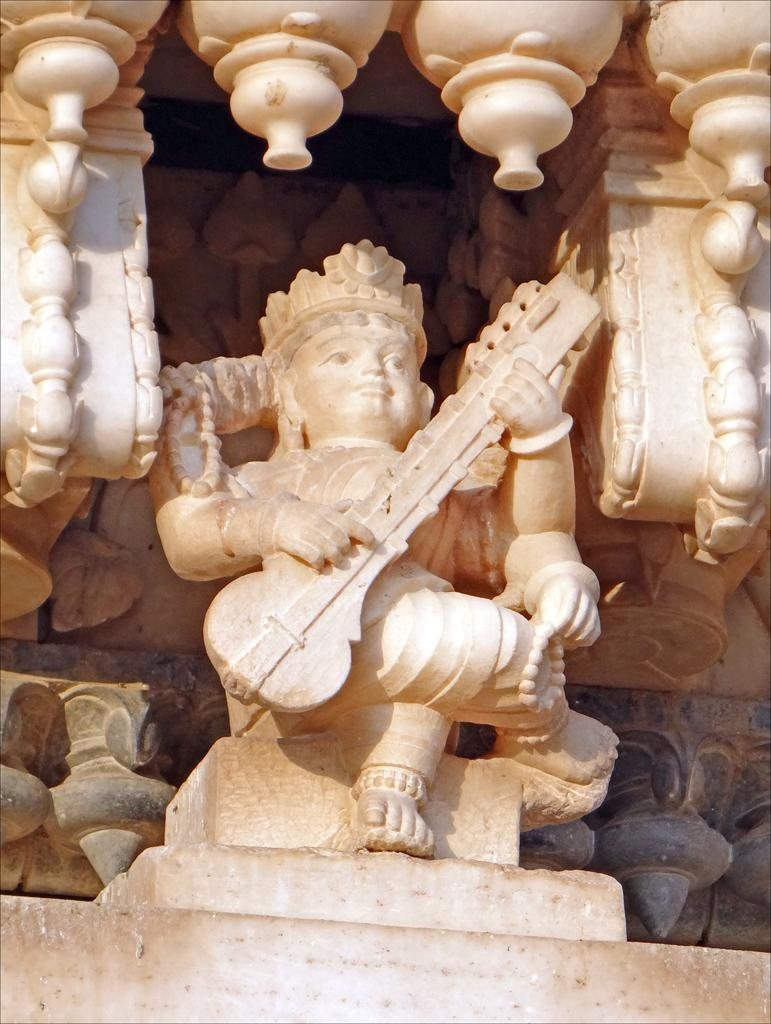What is the main subject in the image? There is a sculpture in the image. Can you describe another object in the image? There is an idol in the image. What color is the eye of the frog in the image? There is no frog present in the image, so there is no eye to describe. 